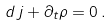<formula> <loc_0><loc_0><loc_500><loc_500>d \, j + { \partial _ { t } \rho } = 0 \, .</formula> 